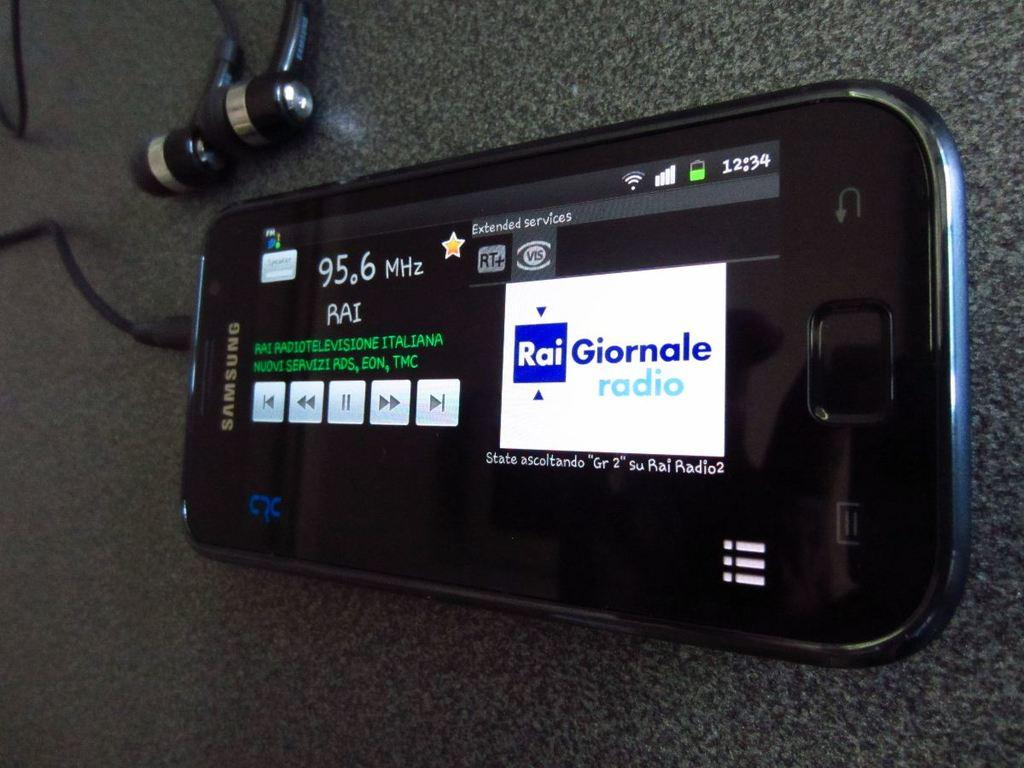What type of device is visible in the image? There is a device with a screen in the image. What can be seen on the screen of the device? The screen displays text. Where is the device located in the image? The device is placed on a surface. What type of accessory is present in the top left corner of the image? There are earphones in the top left corner of the image. What type of carriage is visible in the image? There is no carriage present in the image. What type of skirt is the device wearing in the image? The device is an inanimate object and does not wear clothing, including skirts. 